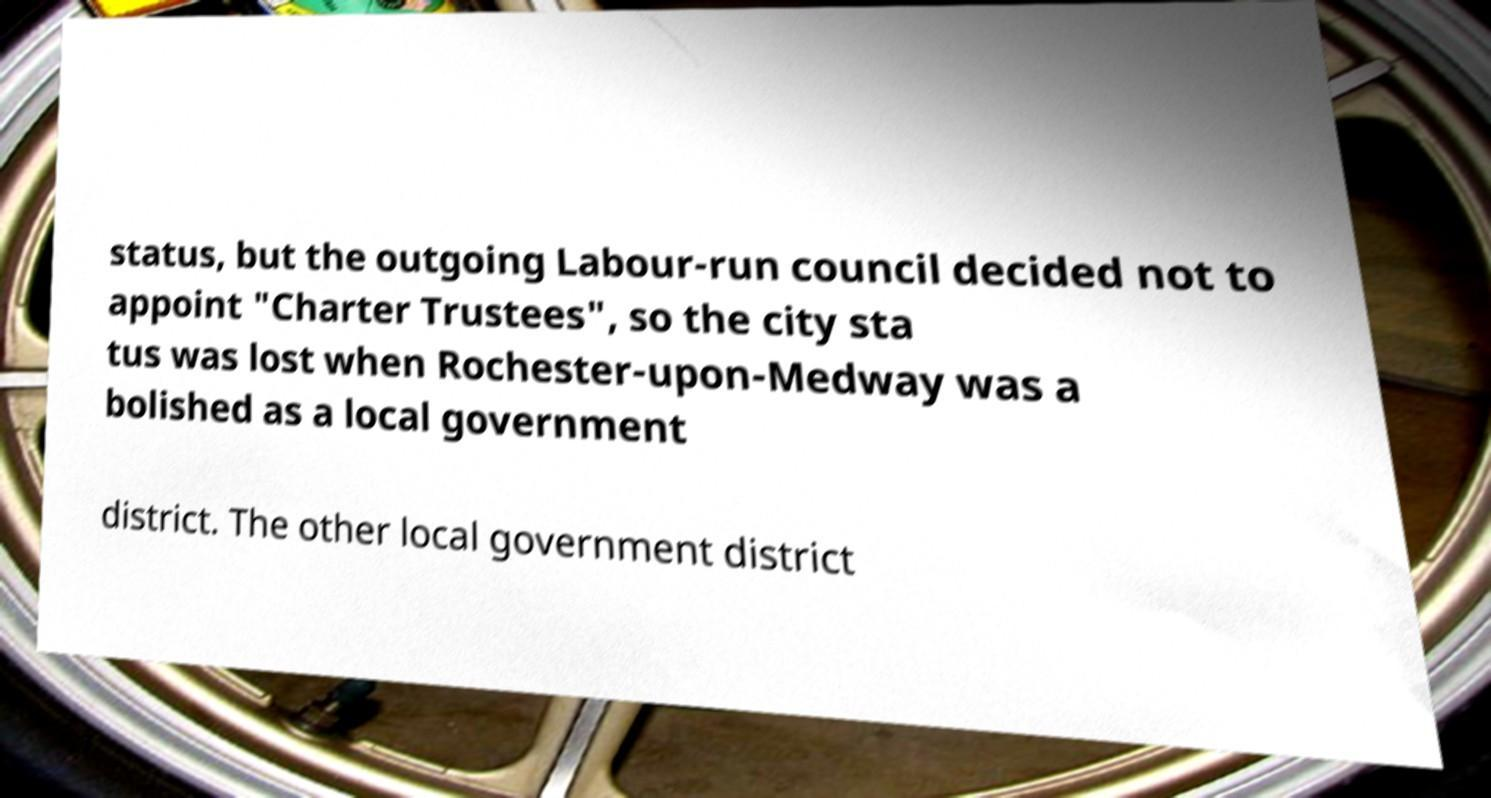Please read and relay the text visible in this image. What does it say? status, but the outgoing Labour-run council decided not to appoint "Charter Trustees", so the city sta tus was lost when Rochester-upon-Medway was a bolished as a local government district. The other local government district 